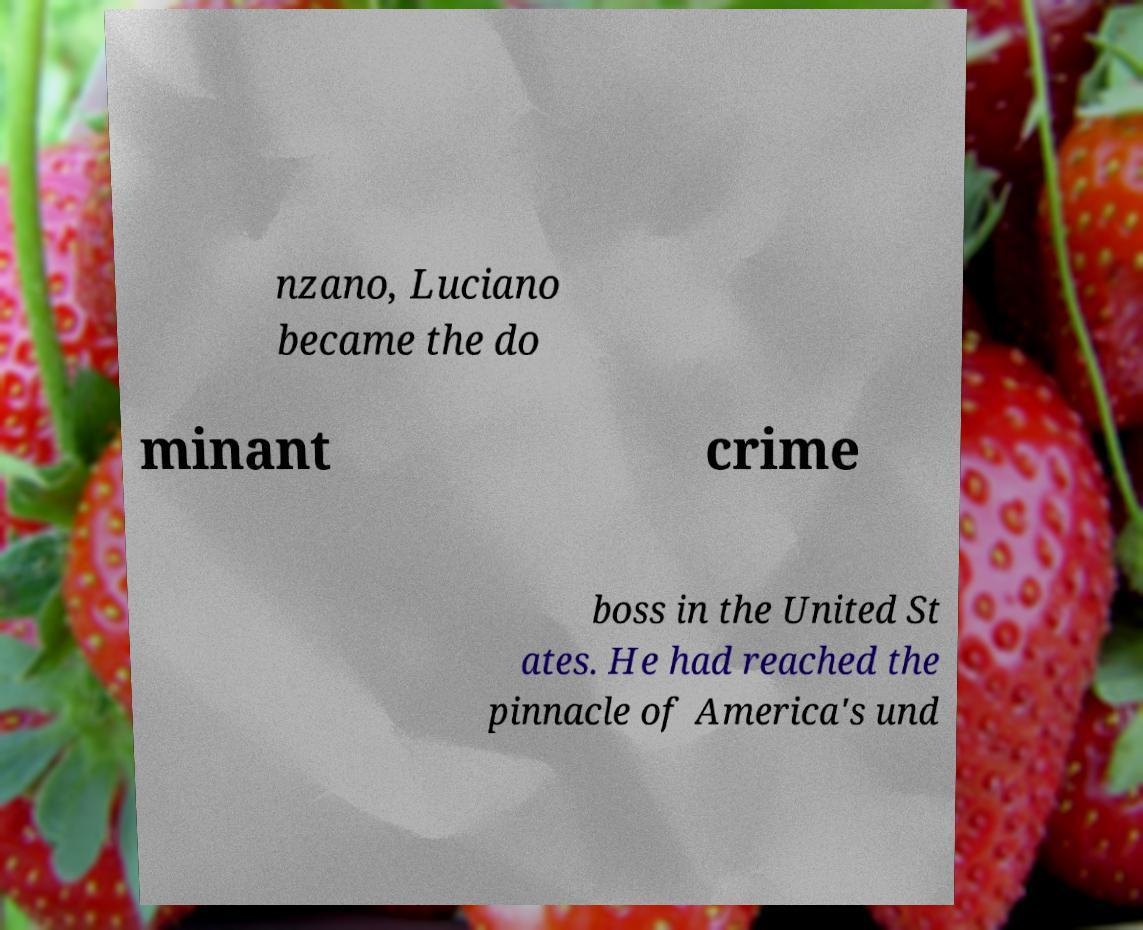Please identify and transcribe the text found in this image. nzano, Luciano became the do minant crime boss in the United St ates. He had reached the pinnacle of America's und 